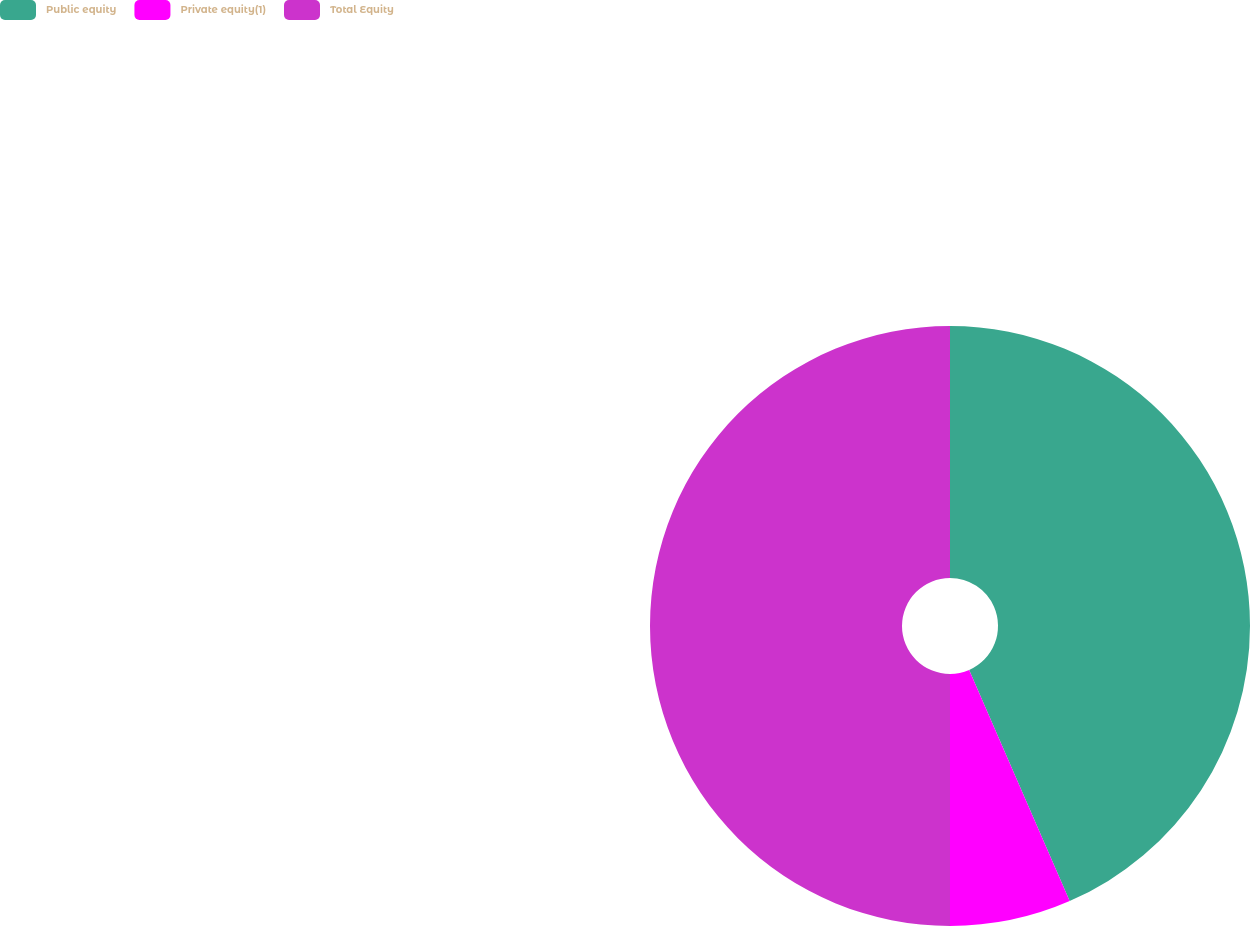<chart> <loc_0><loc_0><loc_500><loc_500><pie_chart><fcel>Public equity<fcel>Private equity(1)<fcel>Total Equity<nl><fcel>43.47%<fcel>6.53%<fcel>50.0%<nl></chart> 